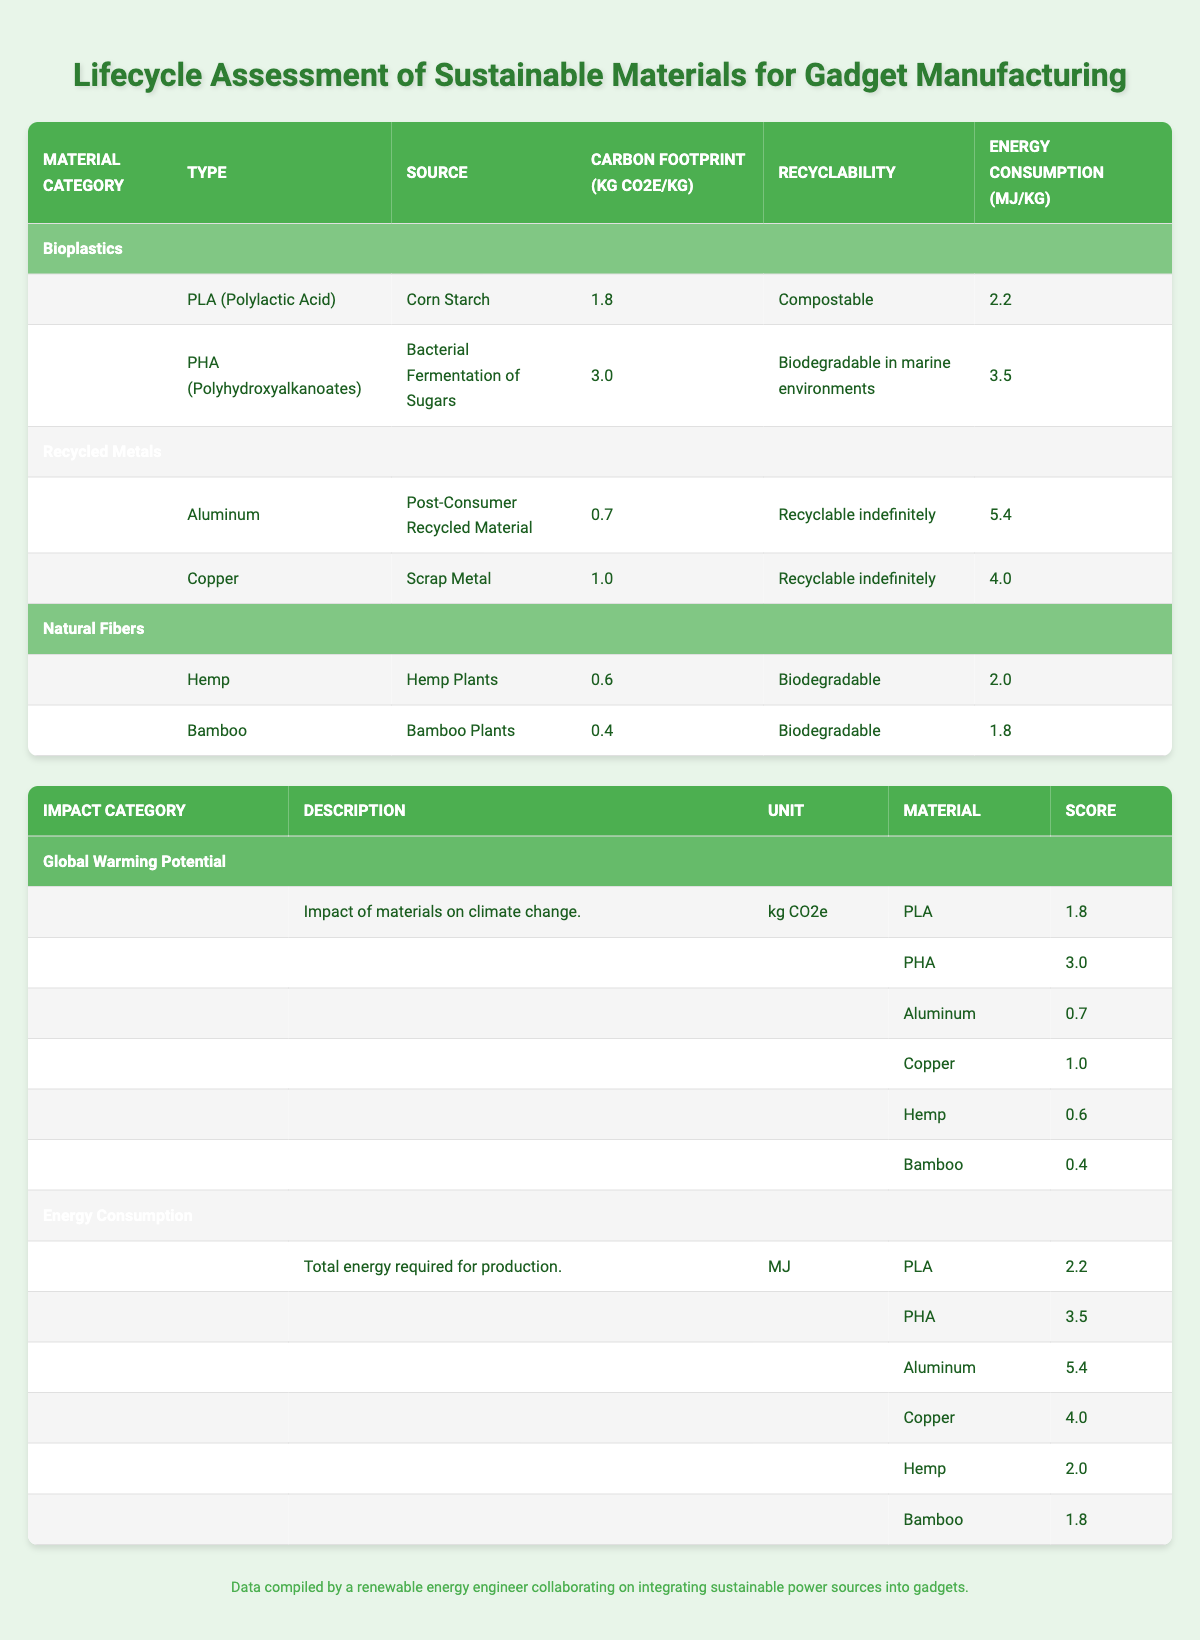What is the carbon footprint of Bamboo? Bamboo has a carbon footprint of 0.4 kg CO2e/kg, as indicated in the Natural Fibers section of the table.
Answer: 0.4 kg CO2e/kg Which bioplastic has the highest energy consumption? PHA (Polyhydroxyalkanoates) has the highest energy consumption at 3.5 MJ/kg, as compared to PLA, which has 2.2 MJ/kg.
Answer: PHA (Polyhydroxyalkanoates) Is Hemp more recyclable than Aluminum? Yes, both materials have different recyclability; Aluminum is recyclable indefinitely, while Hemp is biodegradable. Therefore, Aluminum is more recyclable.
Answer: No What is the average carbon footprint of bioplastics? The carbon footprints for bioplastics are 1.8 kg CO2e/kg (PLA) and 3.0 kg CO2e/kg (PHA). To find the average, add these values (1.8 + 3.0 = 4.8) and divide by the number of bioplastic types (2), resulting in 4.8 / 2 = 2.4 kg CO2e/kg.
Answer: 2.4 kg CO2e/kg How does the carbon footprint of recycled Aluminum compare to natural fibers? The carbon footprint of recycled Aluminum is 0.7 kg CO2e/kg, while the carbon footprints for natural fibers are 0.6 kg CO2e/kg (Hemp) and 0.4 kg CO2e/kg (Bamboo). Since both natural fibers have lower carbon footprints than recycled Aluminum, Aluminum has a higher carbon footprint.
Answer: Higher than both natural fibers Which material type has the lowest energy consumption, and what is its value? The energy consumption values for all materials show that Bamboo has the lowest energy consumption at 1.8 MJ/kg, which is lower than Hemp (2.0 MJ/kg) and all other materials.
Answer: Bamboo, 1.8 MJ/kg What is the total carbon footprint of PLA and Copper combined? The carbon footprint of PLA is 1.8 kg CO2e/kg and Copper is 1.0 kg CO2e/kg. By adding these two values together (1.8 + 1.0), we get a total of 2.8 kg CO2e/kg for both materials combined.
Answer: 2.8 kg CO2e/kg 